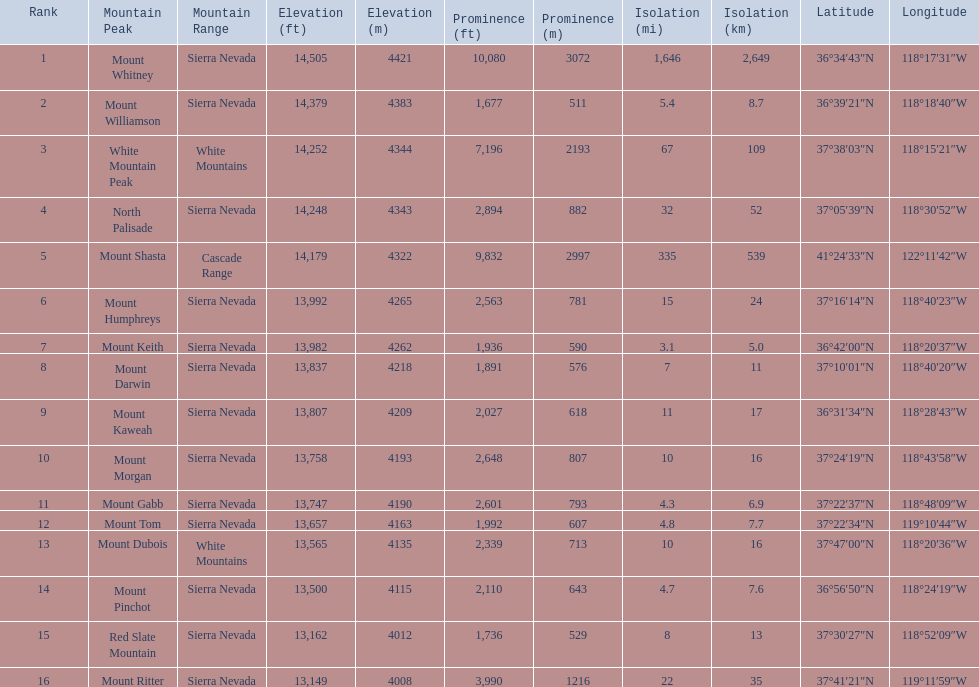What are all of the mountain peaks? Mount Whitney, Mount Williamson, White Mountain Peak, North Palisade, Mount Shasta, Mount Humphreys, Mount Keith, Mount Darwin, Mount Kaweah, Mount Morgan, Mount Gabb, Mount Tom, Mount Dubois, Mount Pinchot, Red Slate Mountain, Mount Ritter. In what ranges are they located? Sierra Nevada, Sierra Nevada, White Mountains, Sierra Nevada, Cascade Range, Sierra Nevada, Sierra Nevada, Sierra Nevada, Sierra Nevada, Sierra Nevada, Sierra Nevada, Sierra Nevada, White Mountains, Sierra Nevada, Sierra Nevada, Sierra Nevada. And which mountain peak is in the cascade range? Mount Shasta. 